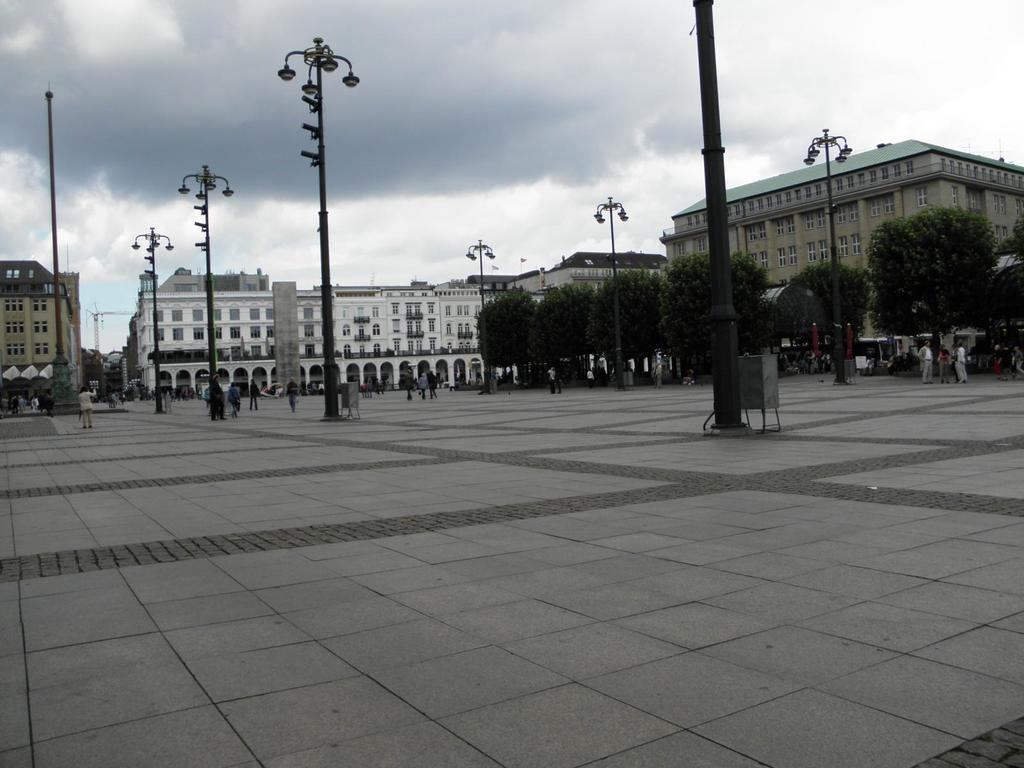What type of structures are located in the middle of the image? There are big buildings in the middle of the image. What else can be seen in the middle of the image besides the buildings? There are street lamps in the middle of the image. How would you describe the sky in the image? The sky is cloudy in the image. Who is the owner of the street lamps in the image? There is no information about the ownership of the street lamps in the image. What type of brush is being used to paint the clouds in the image? There is no brush or painting involved in the image; it is a photograph of a real-life scene. 